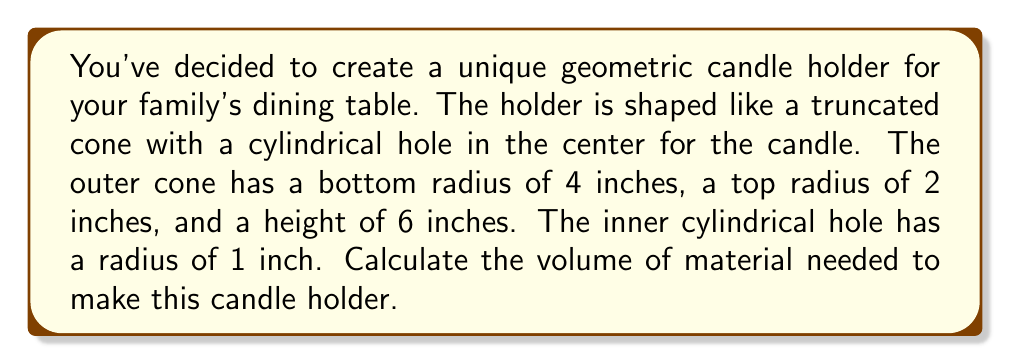Teach me how to tackle this problem. Let's approach this step-by-step:

1. The candle holder is a truncated cone with a cylindrical hole. We need to calculate the volume of the truncated cone and subtract the volume of the cylinder.

2. Volume of a truncated cone:
   $$V_{cone} = \frac{1}{3}\pi h(R^2 + r^2 + Rr)$$
   Where $h$ is the height, $R$ is the bottom radius, and $r$ is the top radius.

3. Substituting the values:
   $$V_{cone} = \frac{1}{3}\pi \cdot 6(4^2 + 2^2 + 4 \cdot 2)$$
   $$V_{cone} = 2\pi(16 + 4 + 8) = 56\pi \text{ cubic inches}$$

4. Volume of the cylindrical hole:
   $$V_{cylinder} = \pi r^2 h$$
   Where $r$ is the radius and $h$ is the height.

5. Substituting the values:
   $$V_{cylinder} = \pi \cdot 1^2 \cdot 6 = 6\pi \text{ cubic inches}$$

6. The volume of material needed is the difference:
   $$V_{material} = V_{cone} - V_{cylinder}$$
   $$V_{material} = 56\pi - 6\pi = 50\pi \text{ cubic inches}$$

[asy]
import three;

size(200);
currentprojection=perspective(6,3,2);

// Draw the truncated cone
path3 base=scale(4)*unitcircle3;
path3 top=shift(0,0,6)*scale(2)*unitcircle3;
surface cone=surface(base--top--cycle);
draw(cone,lightgray);

// Draw the cylindrical hole
path3 inner_base=scale(1)*unitcircle3;
path3 inner_top=shift(0,0,6)*scale(1)*unitcircle3;
surface cylinder=surface(inner_base--inner_top--cycle);
draw(cylinder,white);

// Labels
label("6\"", (4,0,3), E);
label("4\"", (2,-2,0), S);
label("2\"", (1,-1,6), N);
label("1\"", (0.5,0,6), NW);
[/asy]
Answer: $50\pi$ cubic inches 